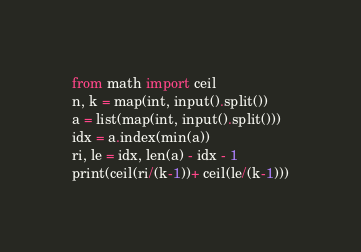Convert code to text. <code><loc_0><loc_0><loc_500><loc_500><_Python_>from math import ceil
n, k = map(int, input().split())
a = list(map(int, input().split()))
idx = a.index(min(a))
ri, le = idx, len(a) - idx - 1
print(ceil(ri/(k-1))+ ceil(le/(k-1)))</code> 